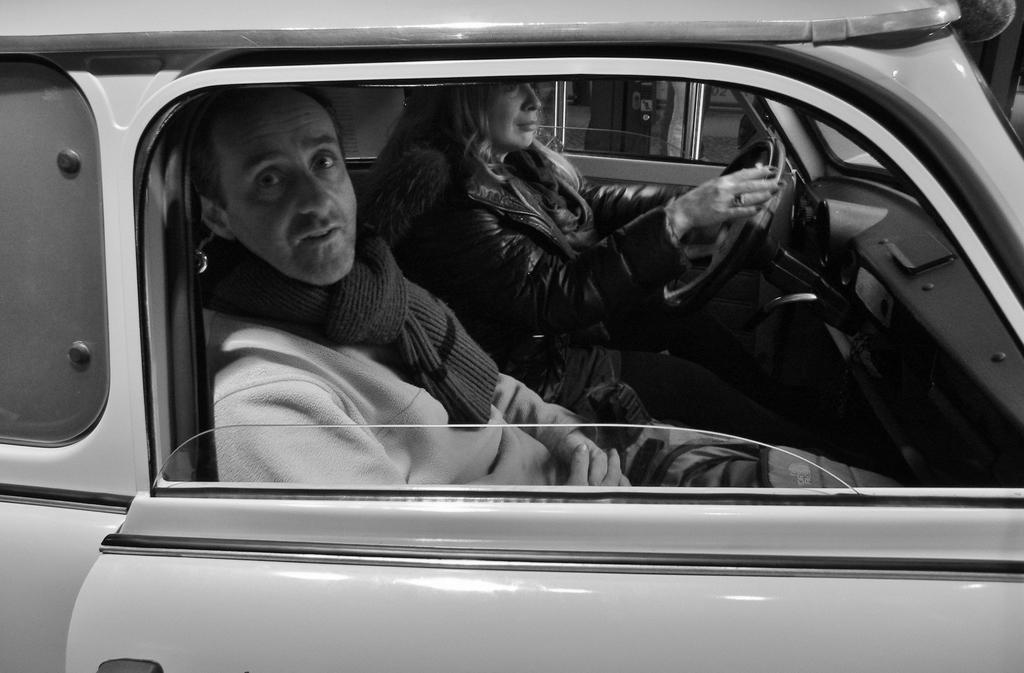What is the main subject of the image? There is a vehicle in the image. Can you describe the position of the person in the vehicle? A person is sitting beside the window of the vehicle. Who else is present in the vehicle? A woman is sitting beside the person. What is the woman doing in the image? The woman is holding the steering of the vehicle. What letters are visible on the bit of the vehicle in the image? There is no bit present in the image, and therefore no letters can be seen on it. 